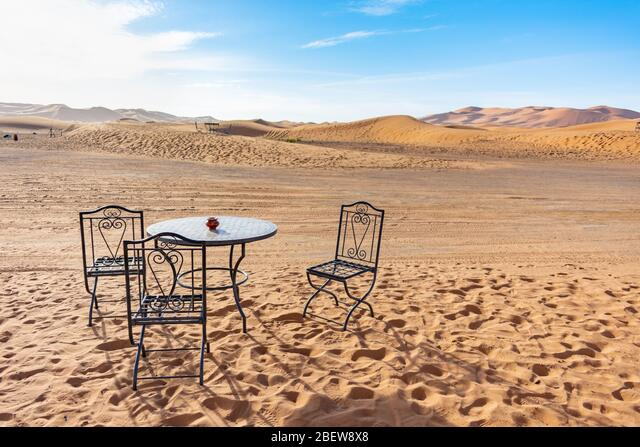Describe the atmosphere conveyed by the setting in the image. The setting evokes a sense of isolation and tranquility, juxtaposing the traditional imagery of a quaint café scene against the expansive and uninterrupted desert dunes stretching to the horizon. How does this setting affect the overall mood of the picture? The unusual placement of the table and chairs in the desert lends the image a dreamlike quality, inviting contemplation about solitude, serenity, and perhaps the unexpected beauty found in vast, empty spaces. 